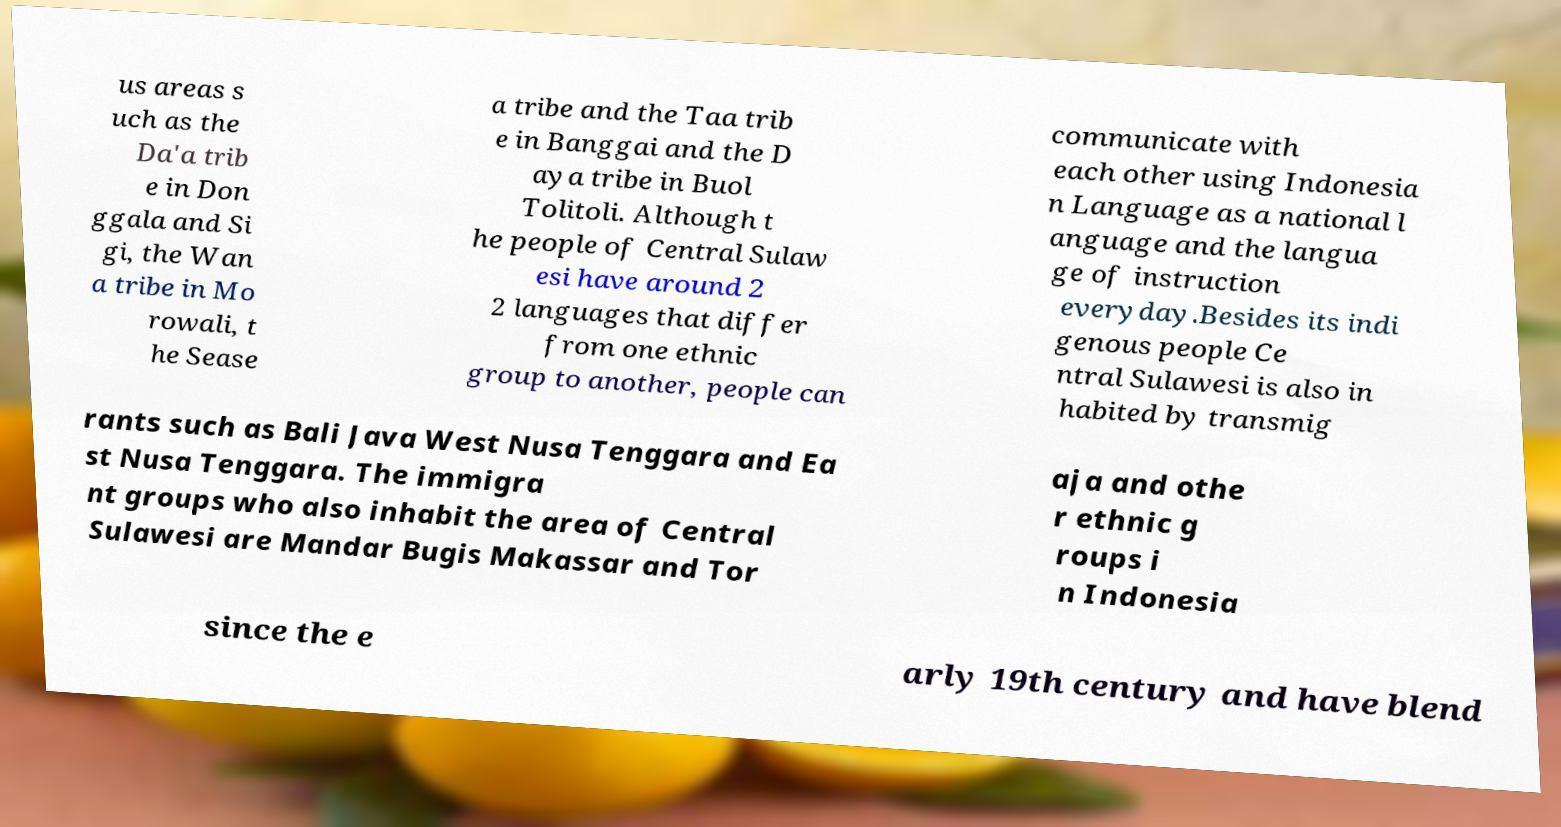What messages or text are displayed in this image? I need them in a readable, typed format. us areas s uch as the Da'a trib e in Don ggala and Si gi, the Wan a tribe in Mo rowali, t he Sease a tribe and the Taa trib e in Banggai and the D aya tribe in Buol Tolitoli. Although t he people of Central Sulaw esi have around 2 2 languages that differ from one ethnic group to another, people can communicate with each other using Indonesia n Language as a national l anguage and the langua ge of instruction everyday.Besides its indi genous people Ce ntral Sulawesi is also in habited by transmig rants such as Bali Java West Nusa Tenggara and Ea st Nusa Tenggara. The immigra nt groups who also inhabit the area of Central Sulawesi are Mandar Bugis Makassar and Tor aja and othe r ethnic g roups i n Indonesia since the e arly 19th century and have blend 